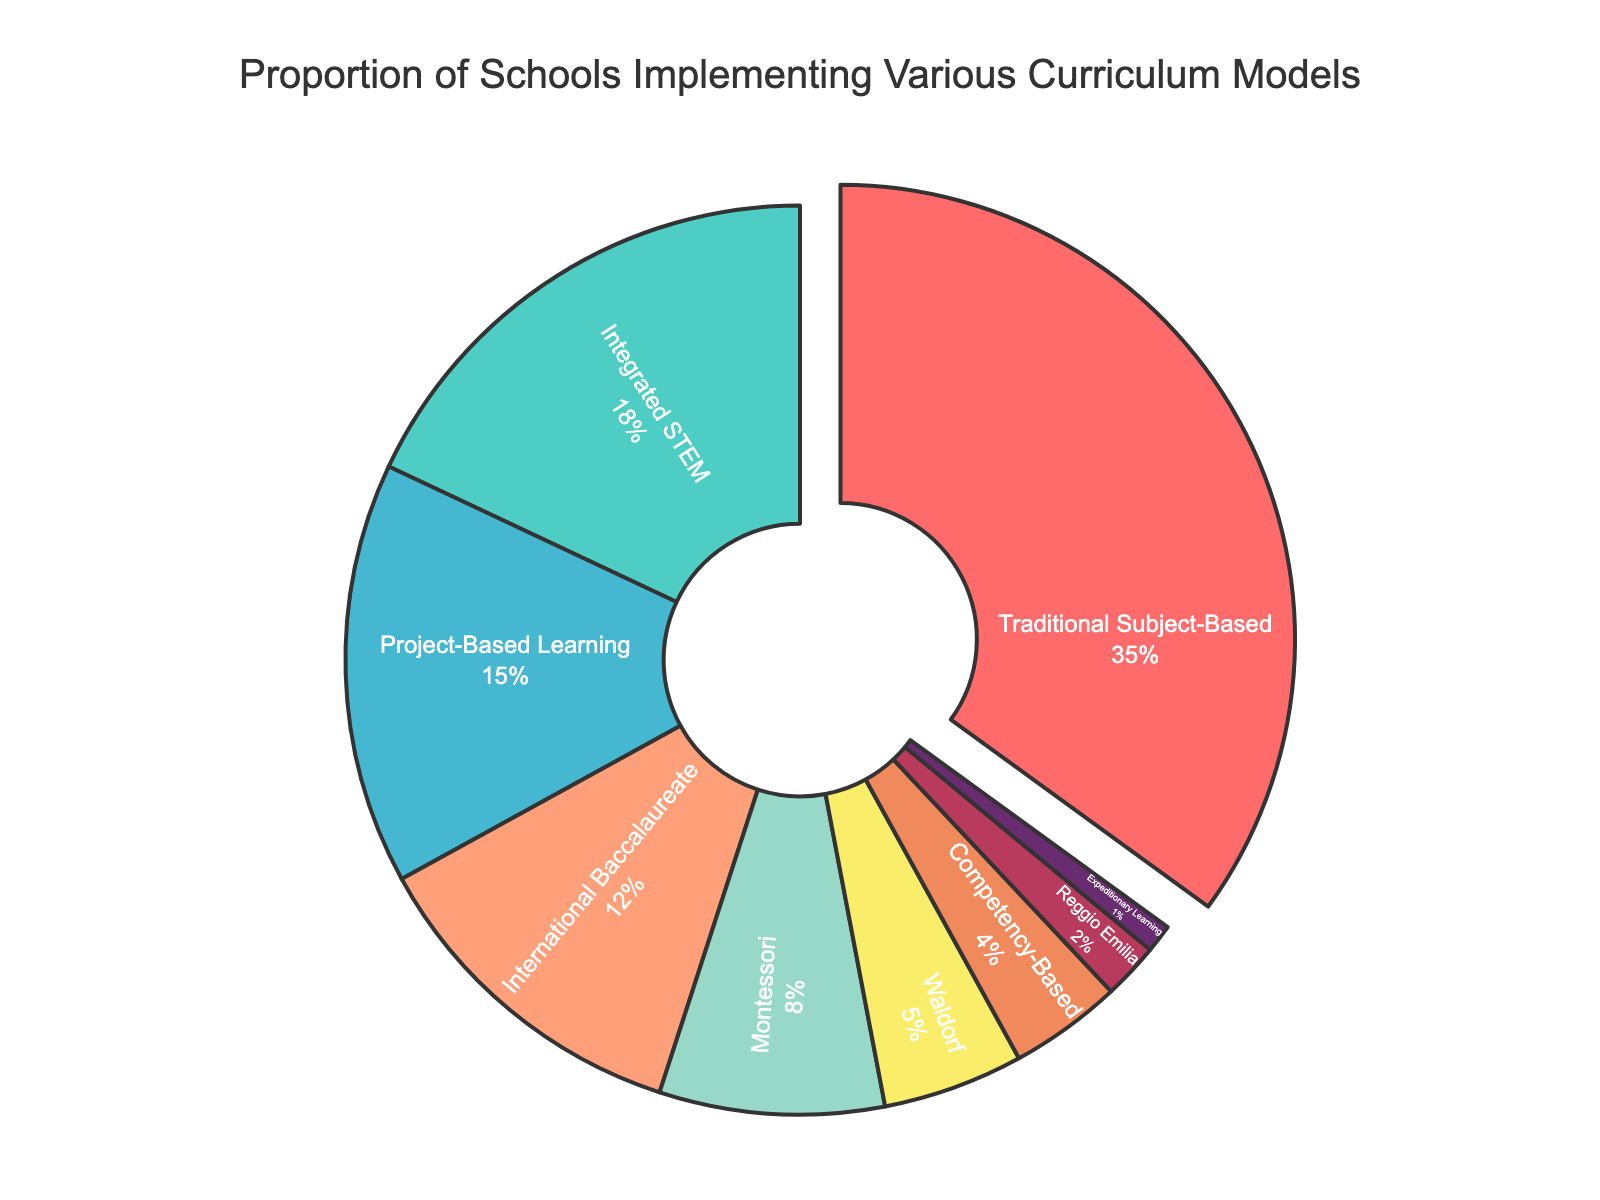What is the percentage of schools implementing the Traditional Subject-Based curriculum model? Refer to the figure's labels and data: the Traditional Subject-Based curriculum model accounts for 35% of schools.
Answer: 35% Which curriculum model has the smallest proportion of implementation among schools? Identify the segment with the smallest percentage by checking the labels and corresponding percentages: Expeditionary Learning is at 1%.
Answer: Expeditionary Learning What is the combined proportion of schools implementing the Montessori and Waldorf curriculum models? Add the percentages for Montessori and Waldorf: 8% (Montessori) + 5% (Waldorf) = 13%.
Answer: 13% How many curriculum models have an implementation rate above 10%? Count the segments with percentages higher than 10%: Traditional Subject-Based (35%), Integrated STEM (18%), Project-Based Learning (15%), and International Baccalaureate (12%). There are four such segments.
Answer: 4 models What is the difference in implementation rates between the Integrated STEM and Competency-Based curriculum models? Subtract the percentage for Competency-Based from Integrated STEM: 18% (Integrated STEM) - 4% (Competency-Based) = 14%.
Answer: 14% Which curriculum model is represented by the red color in the pie chart? The figure's legend indicates color assignments. The red segment corresponds to the Traditional Subject-Based curriculum model.
Answer: Traditional Subject-Based Are there any curriculum models that have the same color shade, and which ones if yes? Observe the color distribution in the pie chart: no two models share the exact same color shade; each segment has a unique color.
Answer: No What is the average implementation rate across all the listed curriculum models? Add all percentages and divide by the number of curriculum models: (35 + 18 + 15 + 12 + 8 + 5 + 4 + 2 + 1) / 9 = 11.11% (approximately).
Answer: 11.11% 